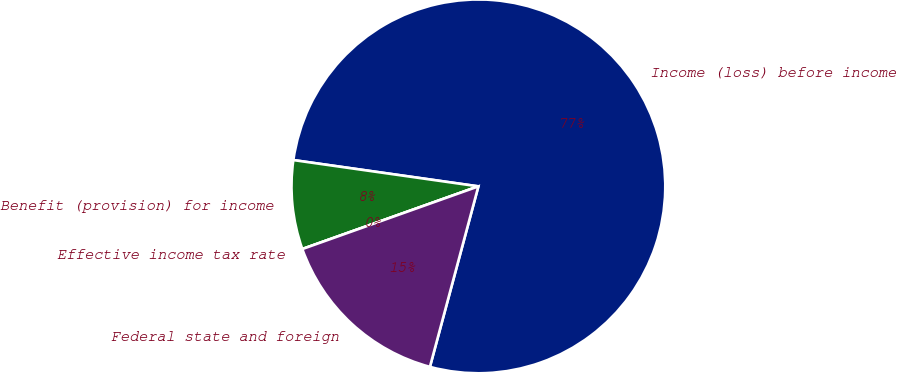Convert chart to OTSL. <chart><loc_0><loc_0><loc_500><loc_500><pie_chart><fcel>Income (loss) before income<fcel>Benefit (provision) for income<fcel>Effective income tax rate<fcel>Federal state and foreign<nl><fcel>76.92%<fcel>7.69%<fcel>0.0%<fcel>15.38%<nl></chart> 